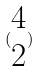Convert formula to latex. <formula><loc_0><loc_0><loc_500><loc_500>( \begin{matrix} 4 \\ 2 \end{matrix} )</formula> 